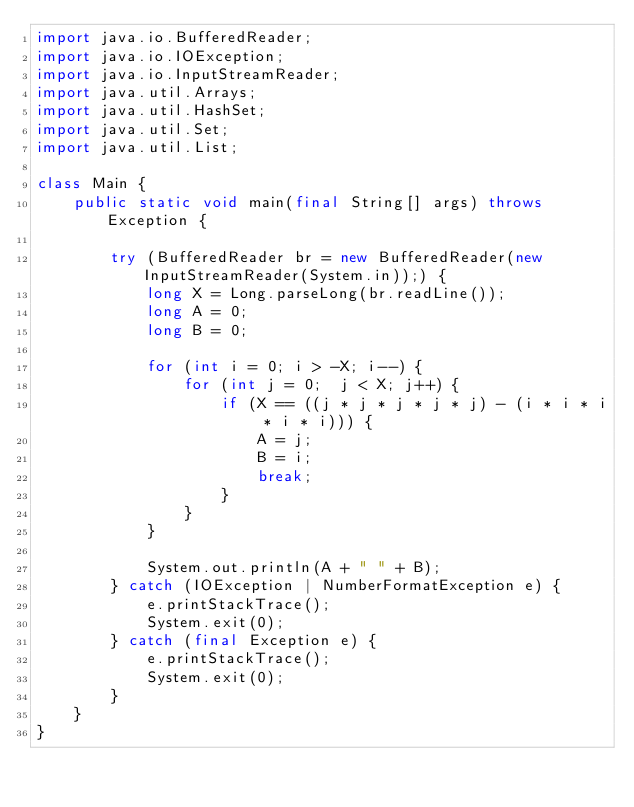<code> <loc_0><loc_0><loc_500><loc_500><_Java_>import java.io.BufferedReader;
import java.io.IOException;
import java.io.InputStreamReader;
import java.util.Arrays;
import java.util.HashSet;
import java.util.Set;
import java.util.List;

class Main {
    public static void main(final String[] args) throws Exception {

        try (BufferedReader br = new BufferedReader(new InputStreamReader(System.in));) {
            long X = Long.parseLong(br.readLine());
            long A = 0;
            long B = 0;

            for (int i = 0; i > -X; i--) {
                for (int j = 0;  j < X; j++) {
                    if (X == ((j * j * j * j * j) - (i * i * i * i * i))) {
                        A = j;
                        B = i;
                        break;
                    }
                }
            }

            System.out.println(A + " " + B);
        } catch (IOException | NumberFormatException e) {
            e.printStackTrace();
            System.exit(0);
        } catch (final Exception e) {
            e.printStackTrace();
            System.exit(0);
        }
    }
}</code> 